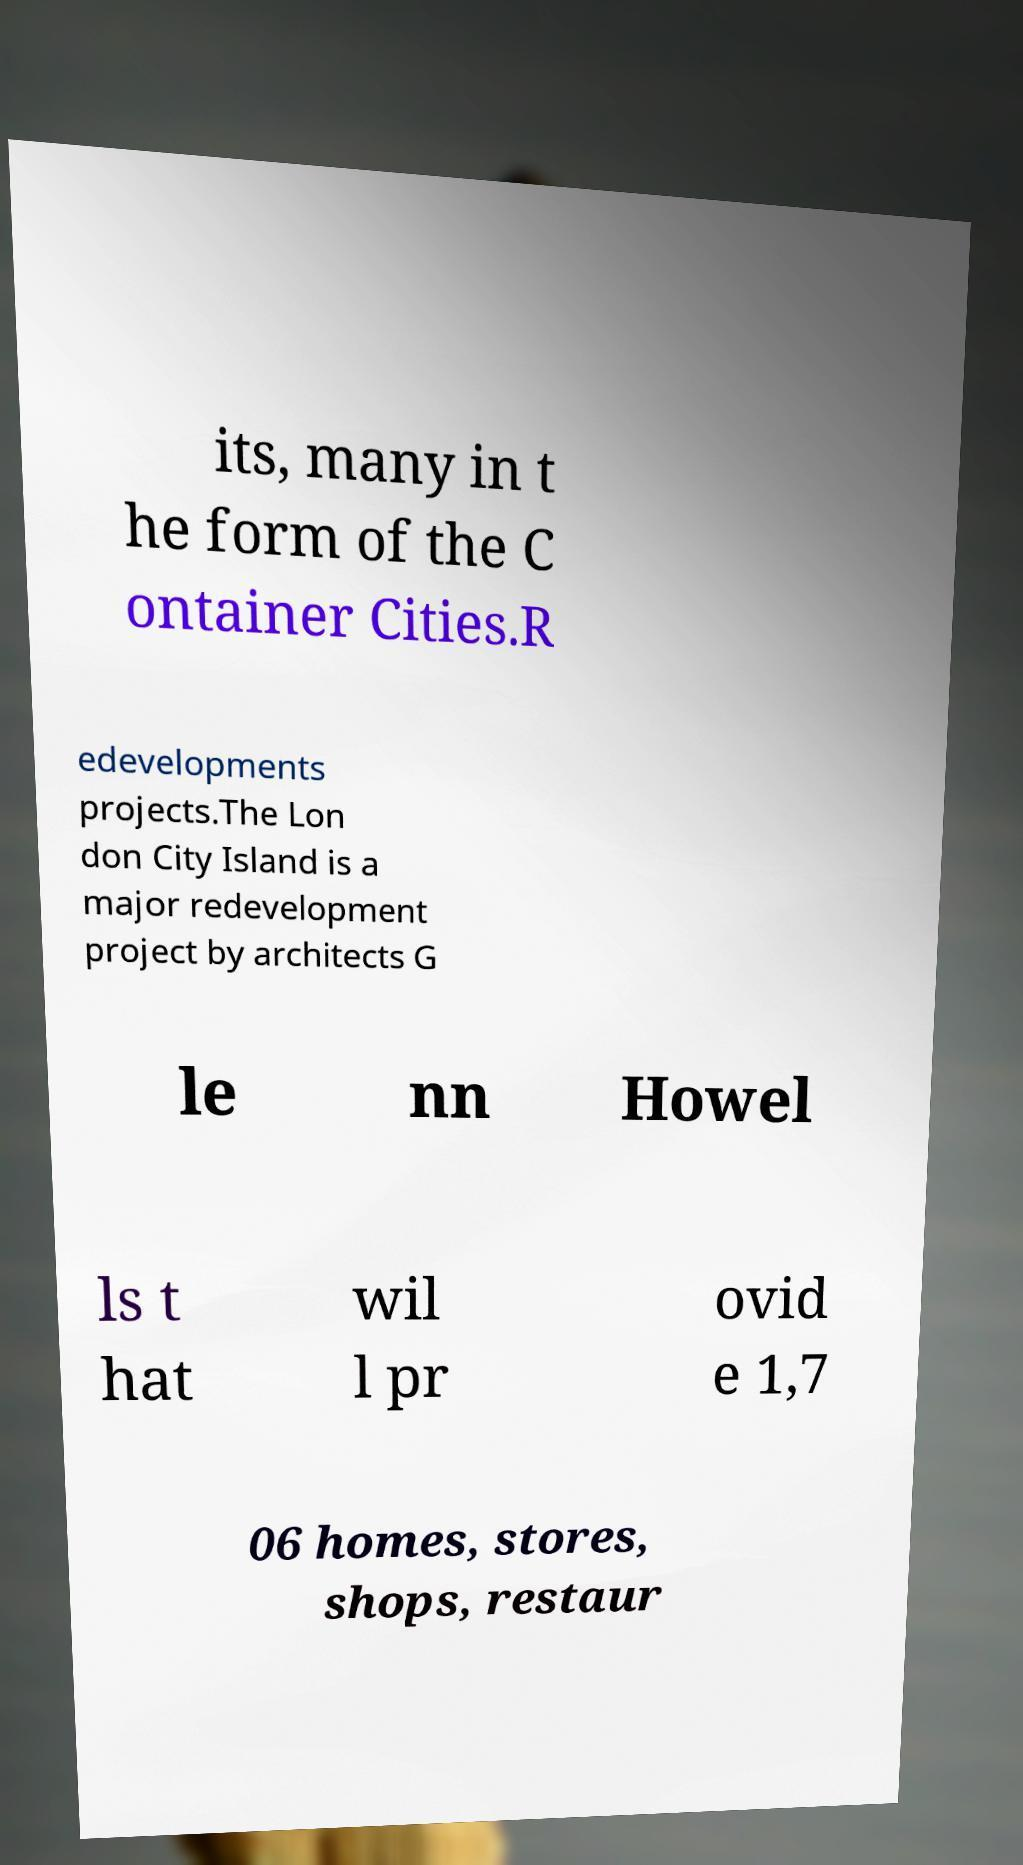There's text embedded in this image that I need extracted. Can you transcribe it verbatim? its, many in t he form of the C ontainer Cities.R edevelopments projects.The Lon don City Island is a major redevelopment project by architects G le nn Howel ls t hat wil l pr ovid e 1,7 06 homes, stores, shops, restaur 